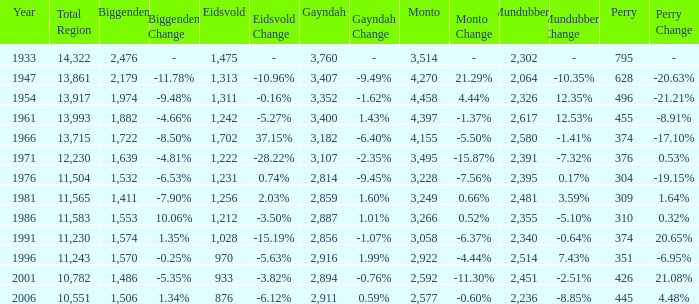Which is the year with Mundubbera being smaller than 2,395, and Biggenden smaller than 1,506? None. 